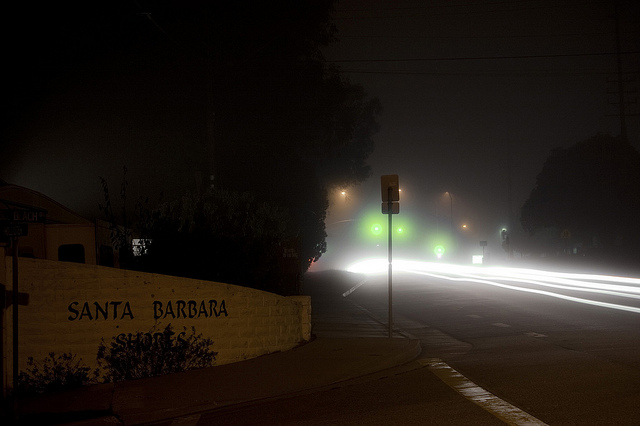Identify the text displayed in this image. SANTA BARBARA 